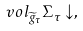Convert formula to latex. <formula><loc_0><loc_0><loc_500><loc_500>v o l _ { \widetilde { g } _ { \tau } } \Sigma _ { \tau } \downarrow ,</formula> 